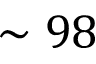<formula> <loc_0><loc_0><loc_500><loc_500>\sim 9 8</formula> 